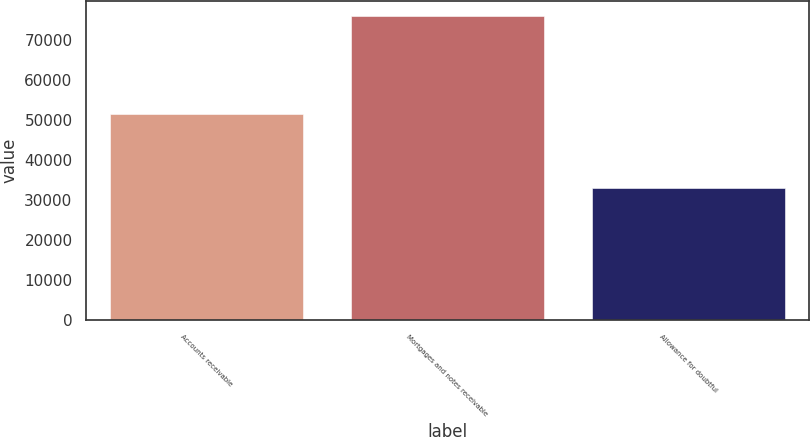<chart> <loc_0><loc_0><loc_500><loc_500><bar_chart><fcel>Accounts receivable<fcel>Mortgages and notes receivable<fcel>Allowance for doubtful<nl><fcel>51491<fcel>76002<fcel>32973<nl></chart> 